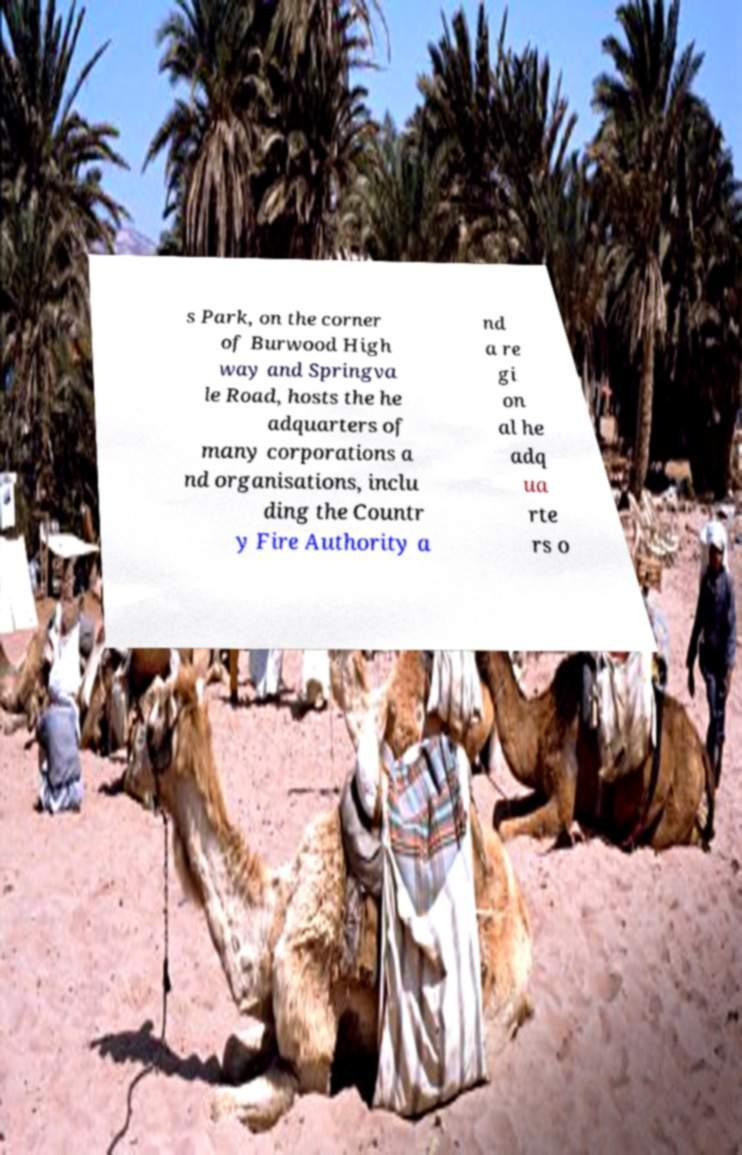There's text embedded in this image that I need extracted. Can you transcribe it verbatim? s Park, on the corner of Burwood High way and Springva le Road, hosts the he adquarters of many corporations a nd organisations, inclu ding the Countr y Fire Authority a nd a re gi on al he adq ua rte rs o 